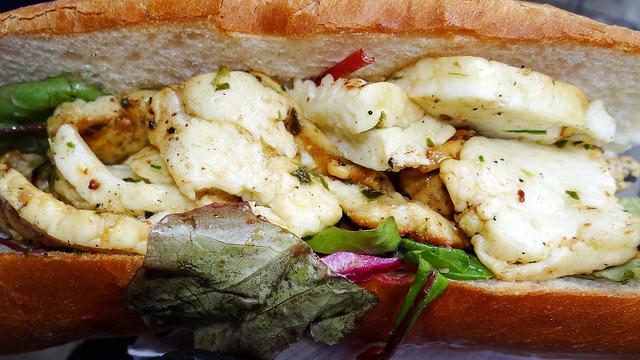What type of meat is there?
Be succinct. Chicken. What kind of bread is this?
Keep it brief. White. What type of meat is in the sandwich?
Concise answer only. Chicken. What is this food?
Keep it brief. Sandwich. 